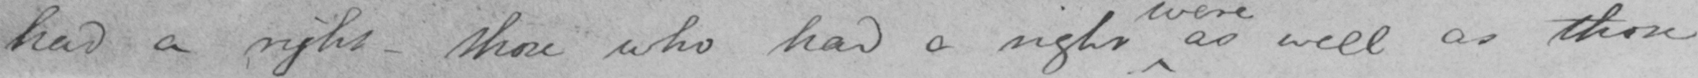Transcribe the text shown in this historical manuscript line. had a right  _  those who had a right as well as those 